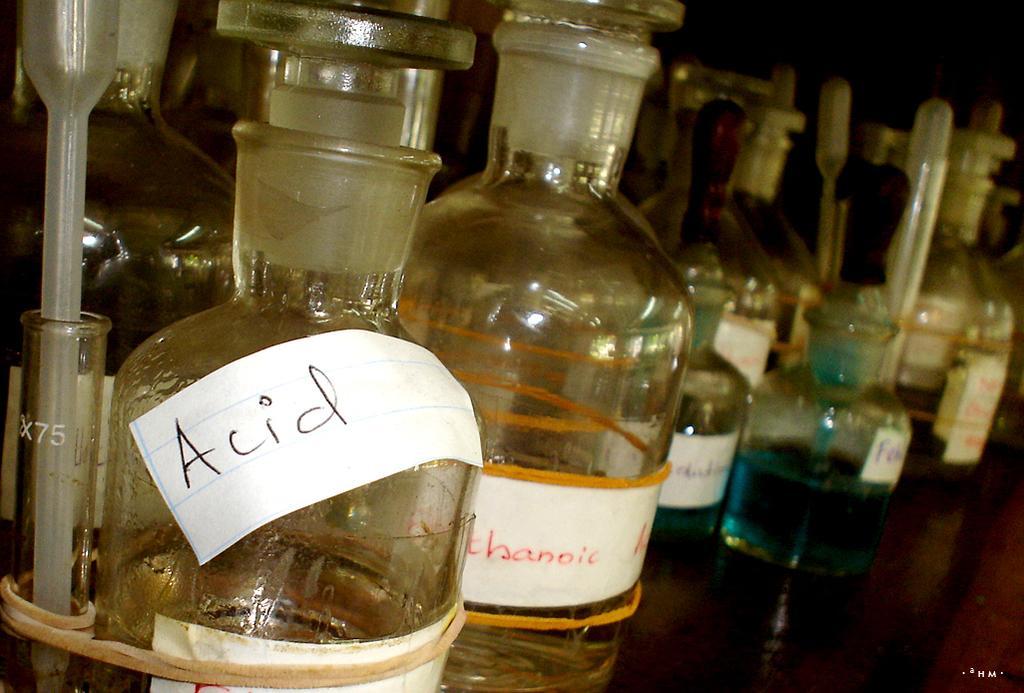In one or two sentences, can you explain what this image depicts? In this picture there are some chemical bottles placed in the shelf. We can observe acid here. All of them were glass material. 